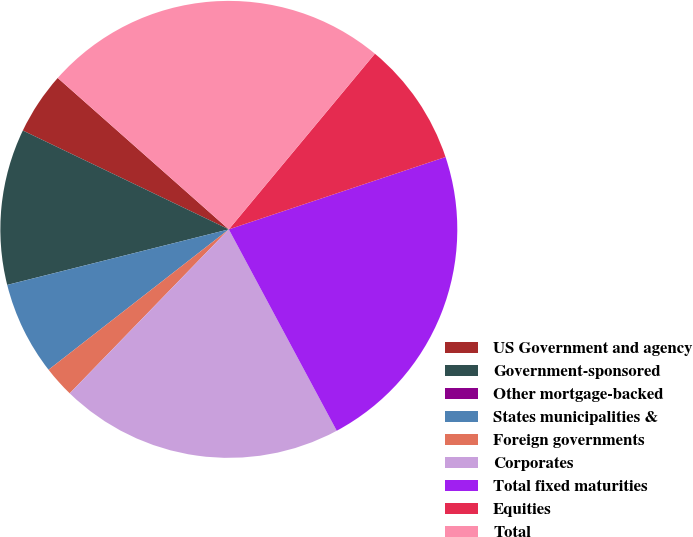Convert chart. <chart><loc_0><loc_0><loc_500><loc_500><pie_chart><fcel>US Government and agency<fcel>Government-sponsored<fcel>Other mortgage-backed<fcel>States municipalities &<fcel>Foreign governments<fcel>Corporates<fcel>Total fixed maturities<fcel>Equities<fcel>Total<nl><fcel>4.41%<fcel>11.03%<fcel>0.0%<fcel>6.62%<fcel>2.21%<fcel>20.09%<fcel>22.3%<fcel>8.83%<fcel>24.51%<nl></chart> 